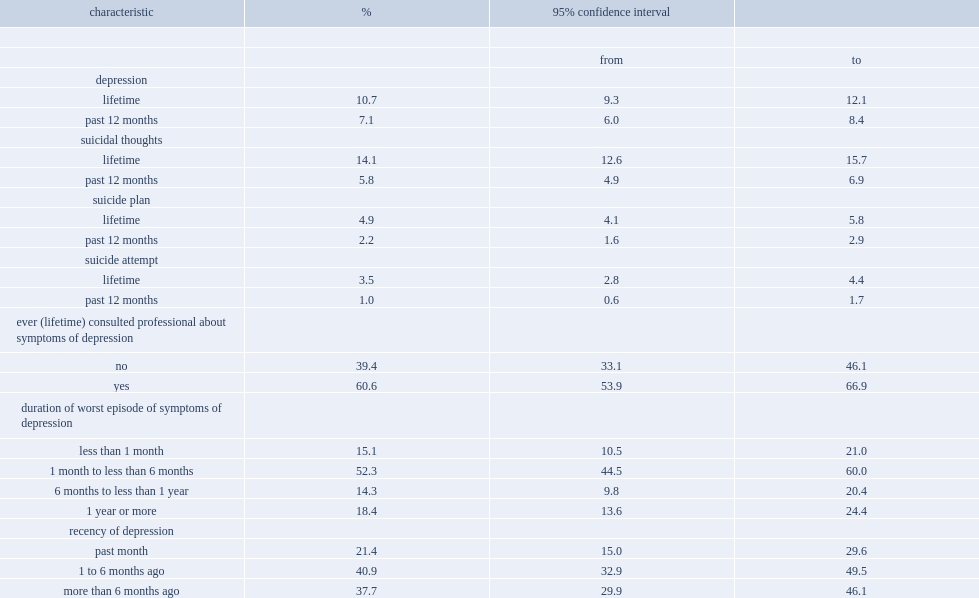What are the percentages of 15- to 24-year-olds who had been depressed in their lifetime and past year? 10.7 7.1. Among those with depression,what's the percentage of those who had talked to a professional about their symptoms in their lifetime? 60.6. What are the percentages of 15- to 24-year-olds reported having had suicidal thoughts at some point in their life and in the past year respectively. 14.1 5.8. Among 15- to 24-year-olds reported having had suicidal thoughts at some point in their lifetime,what are the percentages of those who had made a suicide plan and had attempted suicide respectively? 4.9 3.5. 